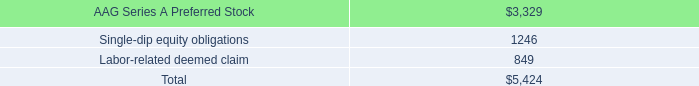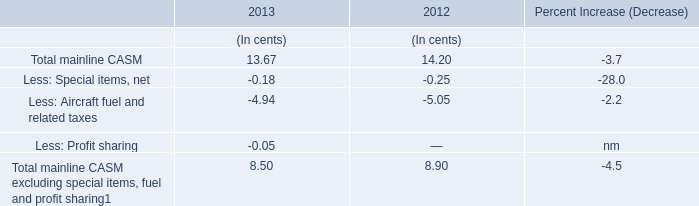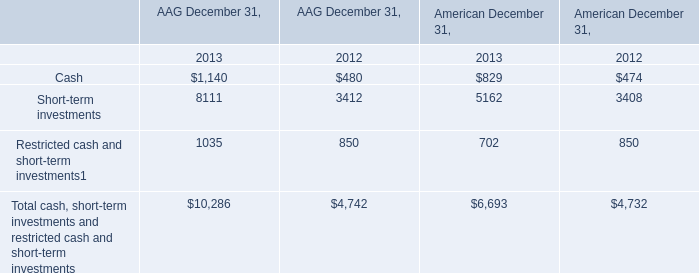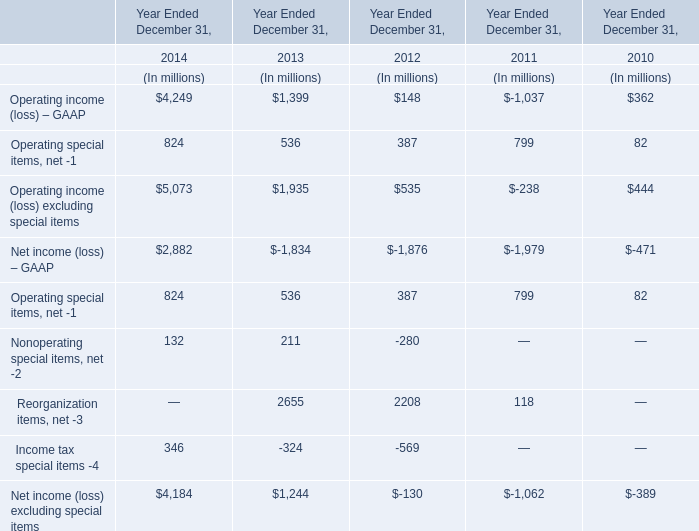If Operating special items, net develops with the same increasing rate in 2014, what will it reach in 2015? (in million) 
Computations: (824 * (1 + ((824 - 536) / 536)))
Answer: 1266.74627. 